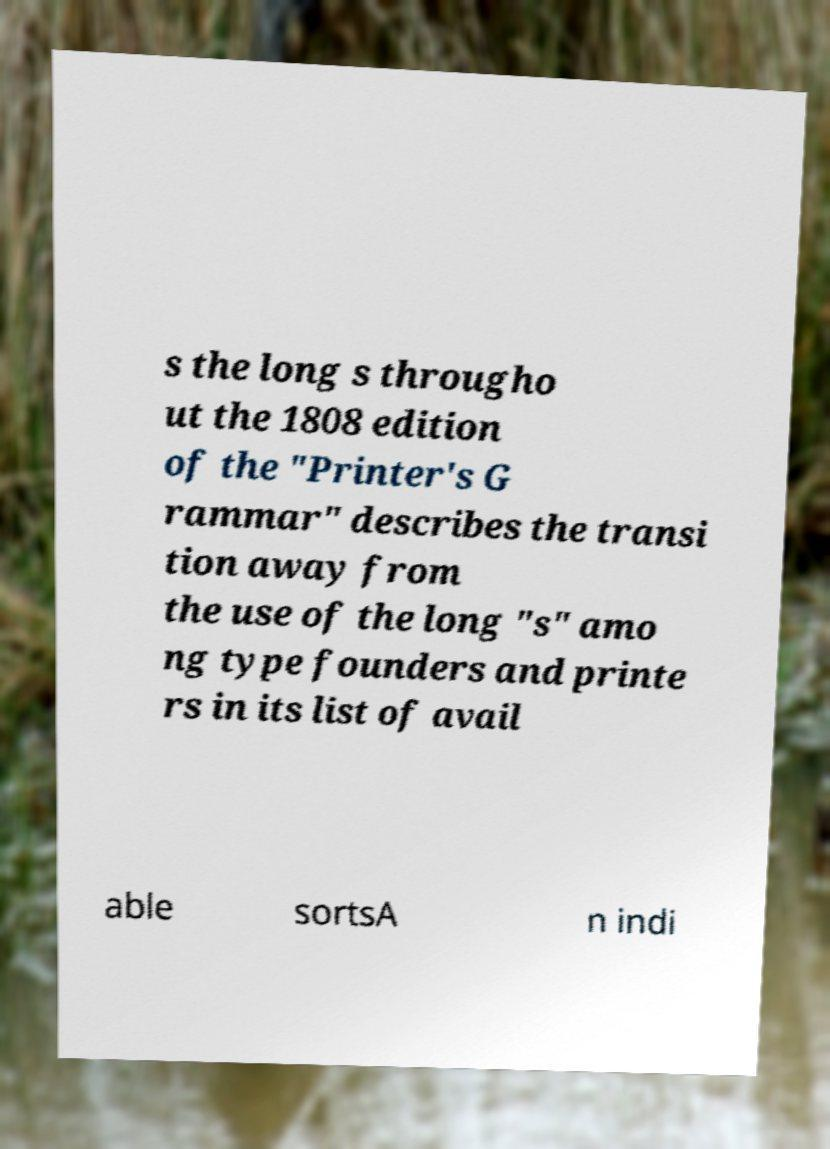Please read and relay the text visible in this image. What does it say? s the long s througho ut the 1808 edition of the "Printer's G rammar" describes the transi tion away from the use of the long "s" amo ng type founders and printe rs in its list of avail able sortsA n indi 